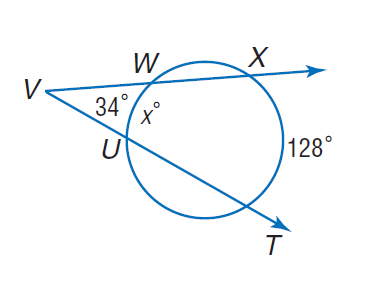Answer the mathemtical geometry problem and directly provide the correct option letter.
Question: Find x.
Choices: A: 34 B: 49 C: 60 D: 128 C 